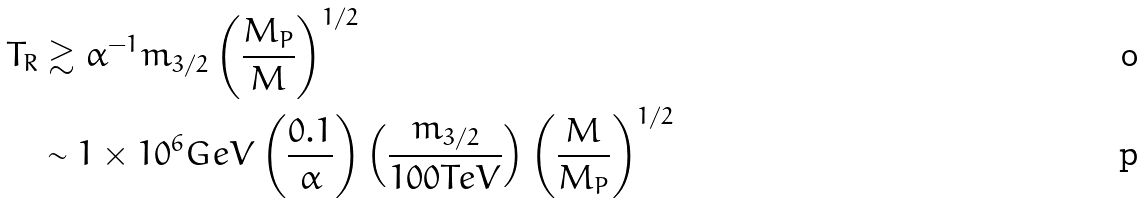Convert formula to latex. <formula><loc_0><loc_0><loc_500><loc_500>T _ { R } & \gtrsim \alpha ^ { - 1 } m _ { 3 / 2 } \left ( \frac { M _ { P } } { M } \right ) ^ { 1 / 2 } \\ & \sim 1 \times 1 0 ^ { 6 } G e V \left ( \frac { 0 . 1 } { \alpha } \right ) \left ( \frac { m _ { 3 / 2 } } { 1 0 0 T e V } \right ) \left ( \frac { M } { M _ { P } } \right ) ^ { 1 / 2 }</formula> 